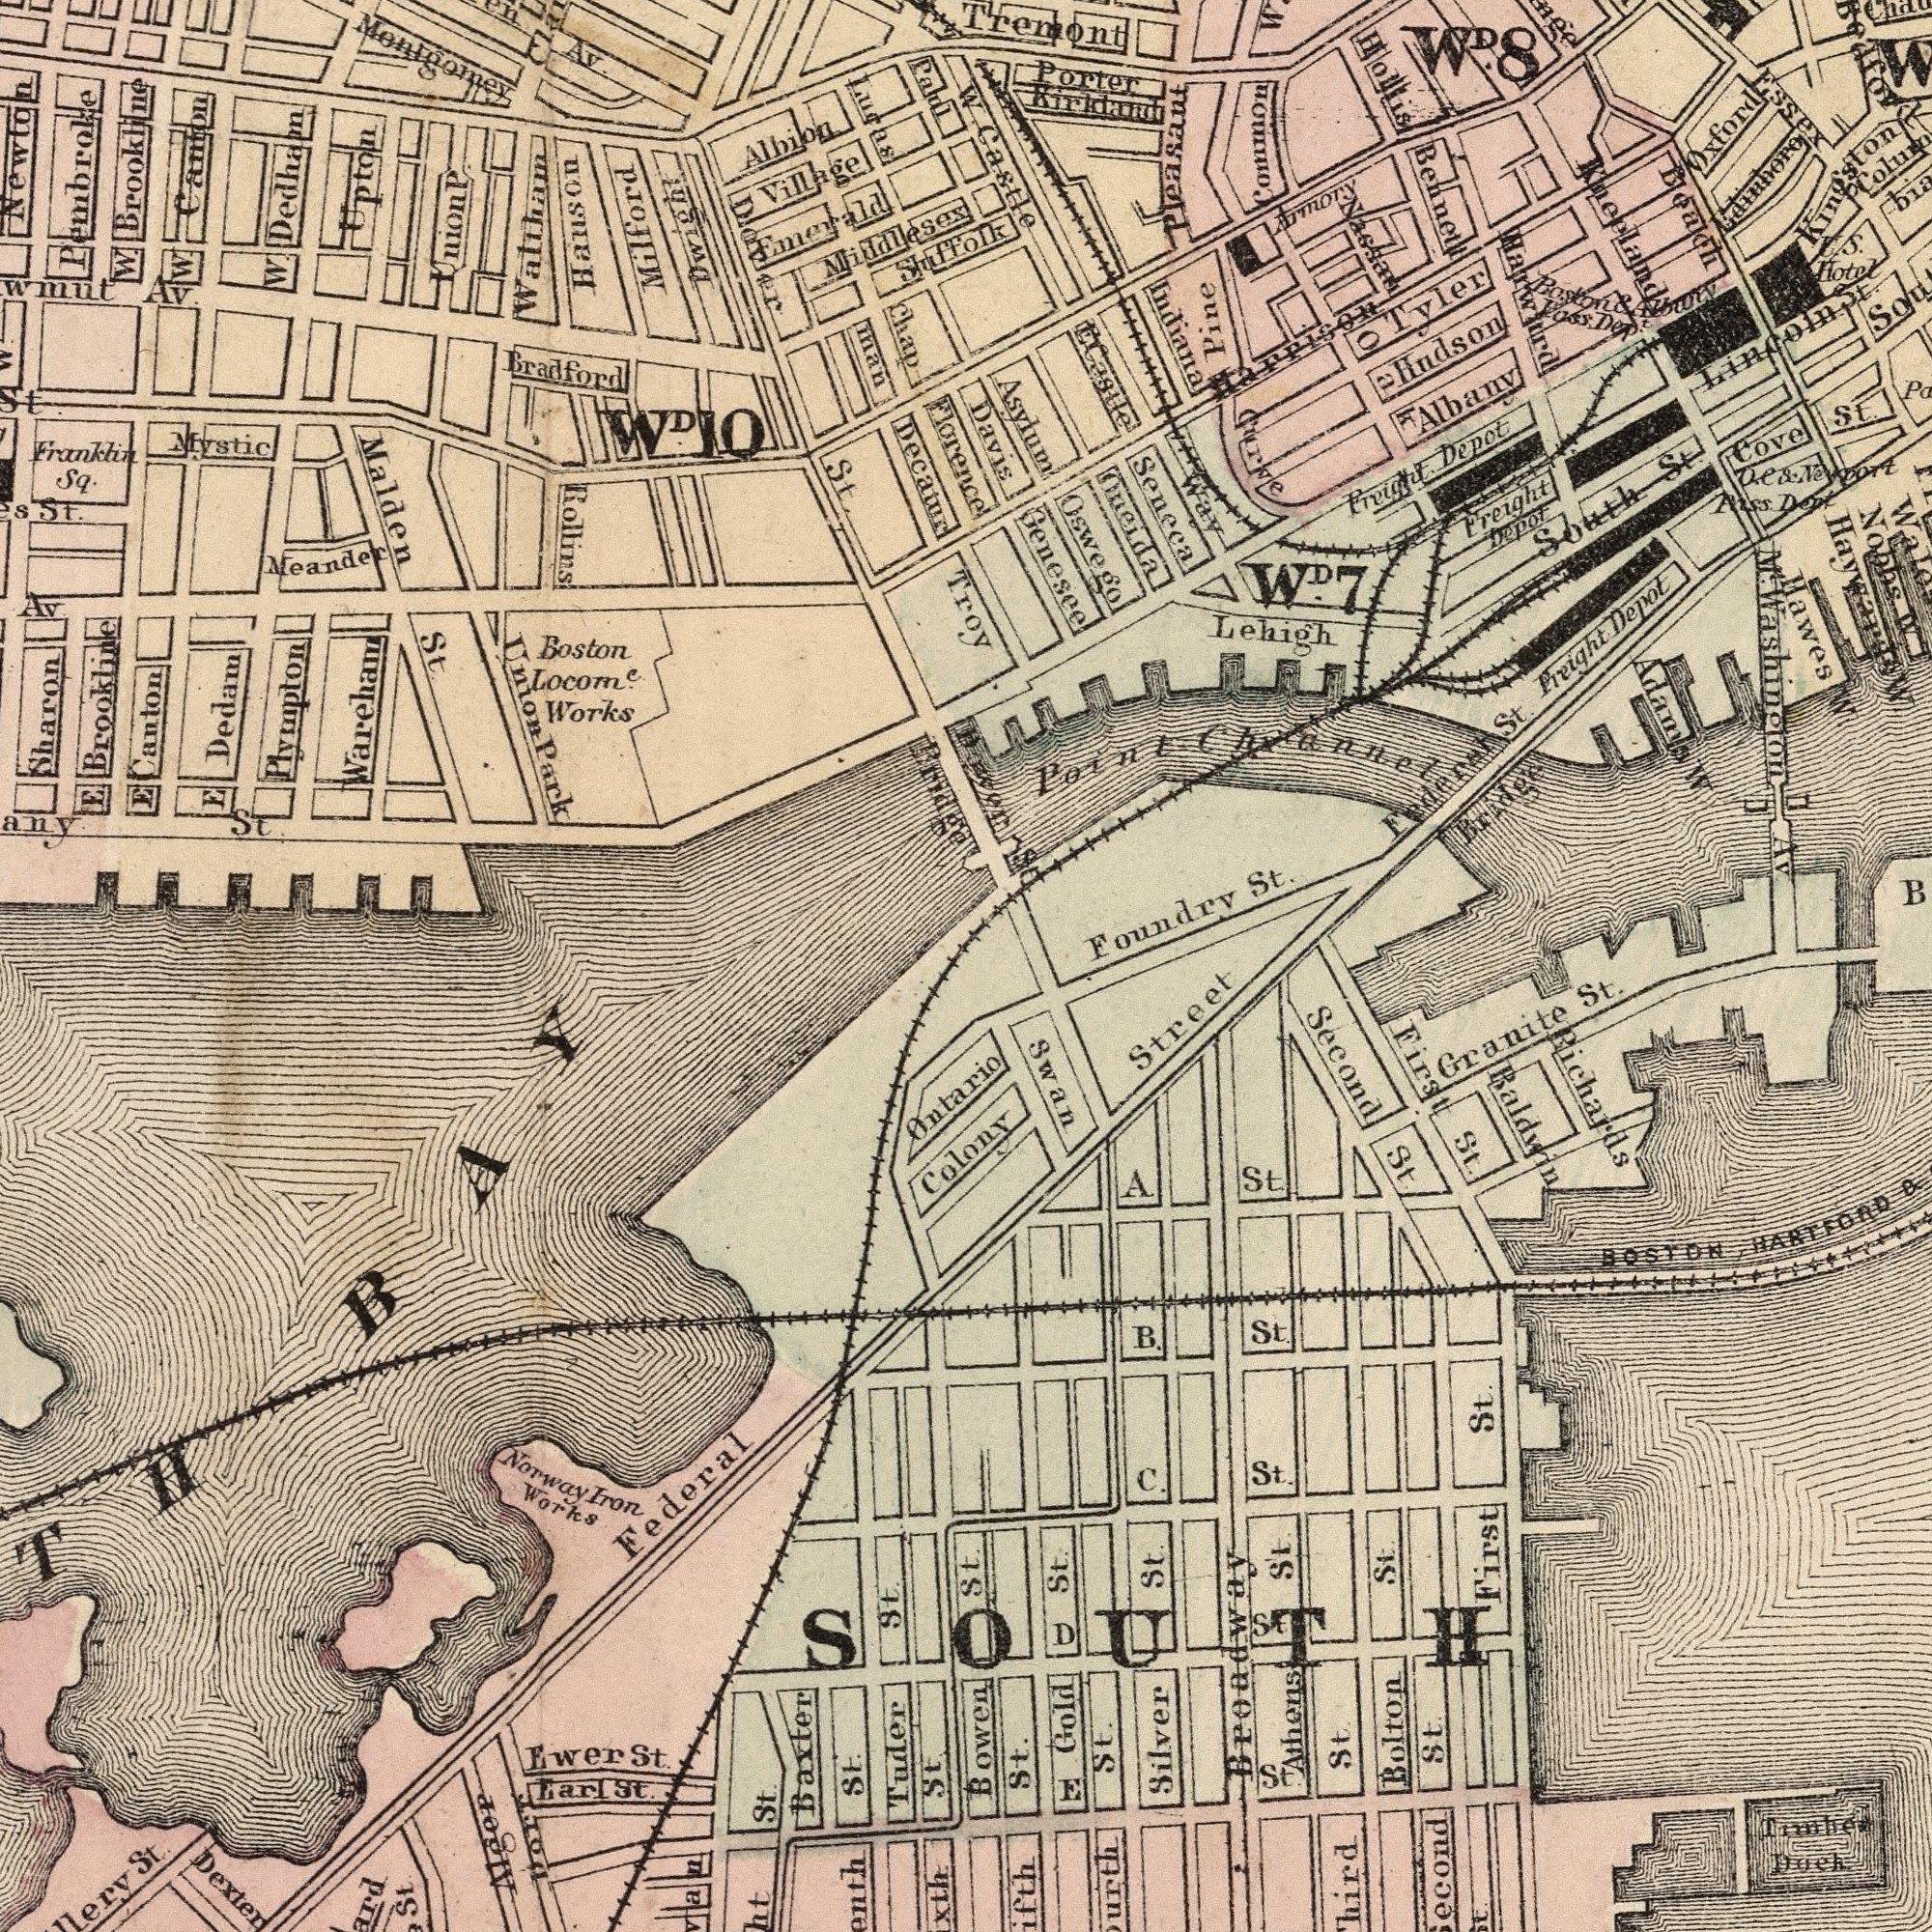What text is visible in the upper-left corner? Milford Decatur Waltham Brookline Park Dover Works Frankhin Chap Rollins Meander Lucas man Village Dedam Montgomey Paul Av. Canton Locomc. Canton W. Sq. Albion St. Newton Boston Malden Middlesex Bridge Florence Brookline Av. W. St. St. E Hanson E Pembroke Wareham St. E Bradford Upton Av. WD.10 Sharon Plympton W. Union Dedham Dwight W. Emerald Shuffolk Union Mystic p What text appears in the bottom-left area of the image? Federal St. Baxter Dexten St. Works Tuder St. St. St. Ontario St. St. Earl St. Norway Ewer Iron Dorr BAY Algep What text is visible in the upper-right corner? Seneca St. Davis Castle Foundry Indiana South Asylum Hollis Common Genesee Cove Way Pine Oswego Curve Bridge Tremont Lehigh St. Adama Bennett Depot Freight Freight Pass Hudson Ecastle Depot Albany Freight Porter Depot Nobbs St. Dept Edinboro Federat Hotel U. St. Kirkland Armory Hawes Tyler Pleasant Beach Dep Oneida Av Happison WD.8 Dover Oxford Troy W. W. Point Nassau Kneelands St. W Pass Harwird W Essex Kingston Lincoln St. Oak W. M<sup>t</sup>. Washington WD.7 Boston & S. Des. What text can you see in the bottom-right section? HARTFORD Bolton St. Dock Street St. Granite Broadway Richards St. Silver St. Gold St. St. BOSTON First Second St. Athens First St. St. St. St. C. Baldwin St. B. St. St. A St. & Bowen Swan St. Timber St. Colony St D SOUTH E 